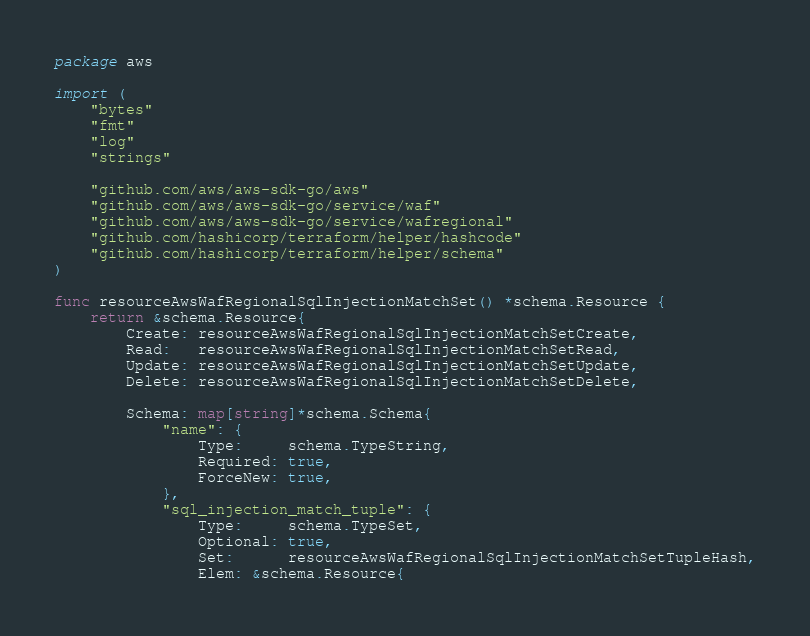<code> <loc_0><loc_0><loc_500><loc_500><_Go_>package aws

import (
	"bytes"
	"fmt"
	"log"
	"strings"

	"github.com/aws/aws-sdk-go/aws"
	"github.com/aws/aws-sdk-go/service/waf"
	"github.com/aws/aws-sdk-go/service/wafregional"
	"github.com/hashicorp/terraform/helper/hashcode"
	"github.com/hashicorp/terraform/helper/schema"
)

func resourceAwsWafRegionalSqlInjectionMatchSet() *schema.Resource {
	return &schema.Resource{
		Create: resourceAwsWafRegionalSqlInjectionMatchSetCreate,
		Read:   resourceAwsWafRegionalSqlInjectionMatchSetRead,
		Update: resourceAwsWafRegionalSqlInjectionMatchSetUpdate,
		Delete: resourceAwsWafRegionalSqlInjectionMatchSetDelete,

		Schema: map[string]*schema.Schema{
			"name": {
				Type:     schema.TypeString,
				Required: true,
				ForceNew: true,
			},
			"sql_injection_match_tuple": {
				Type:     schema.TypeSet,
				Optional: true,
				Set:      resourceAwsWafRegionalSqlInjectionMatchSetTupleHash,
				Elem: &schema.Resource{</code> 